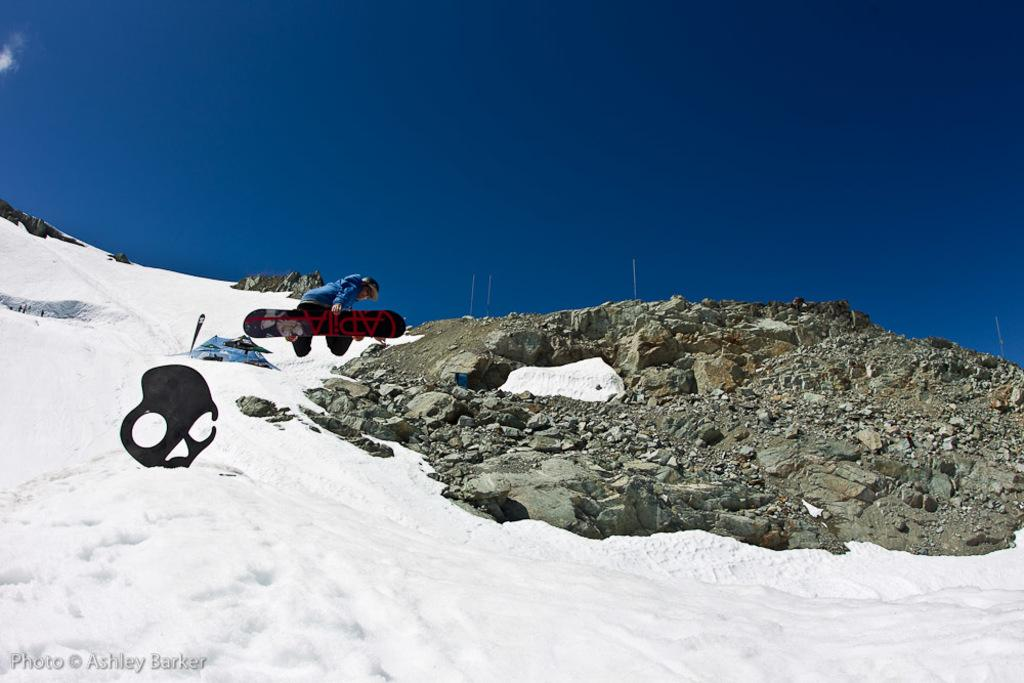What is the person in the image doing? The person is on a snowboard in the image. What is the person's position in relation to the ground? The person is in the air. What type of shelter can be seen in the image? There is a tent in the image. What is the ground made of in the image? There is snow in the image. What type of natural feature can be seen in the image? There are rocks in the image. What else is present in the image besides the person, tent, and rocks? There are some objects in the image. What can be seen in the background of the image? The sky is visible in the background of the image. What type of thunder can be heard in the image? There is no thunder present in the image, as it is a visual medium and does not include sound. 